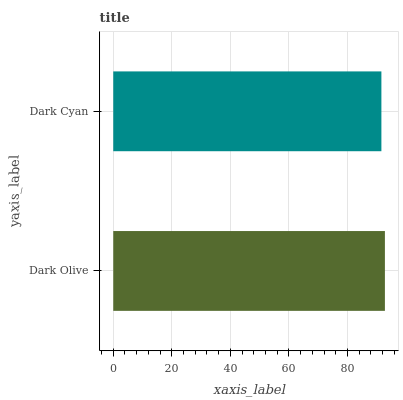Is Dark Cyan the minimum?
Answer yes or no. Yes. Is Dark Olive the maximum?
Answer yes or no. Yes. Is Dark Cyan the maximum?
Answer yes or no. No. Is Dark Olive greater than Dark Cyan?
Answer yes or no. Yes. Is Dark Cyan less than Dark Olive?
Answer yes or no. Yes. Is Dark Cyan greater than Dark Olive?
Answer yes or no. No. Is Dark Olive less than Dark Cyan?
Answer yes or no. No. Is Dark Olive the high median?
Answer yes or no. Yes. Is Dark Cyan the low median?
Answer yes or no. Yes. Is Dark Cyan the high median?
Answer yes or no. No. Is Dark Olive the low median?
Answer yes or no. No. 